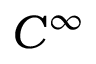<formula> <loc_0><loc_0><loc_500><loc_500>C ^ { \infty }</formula> 